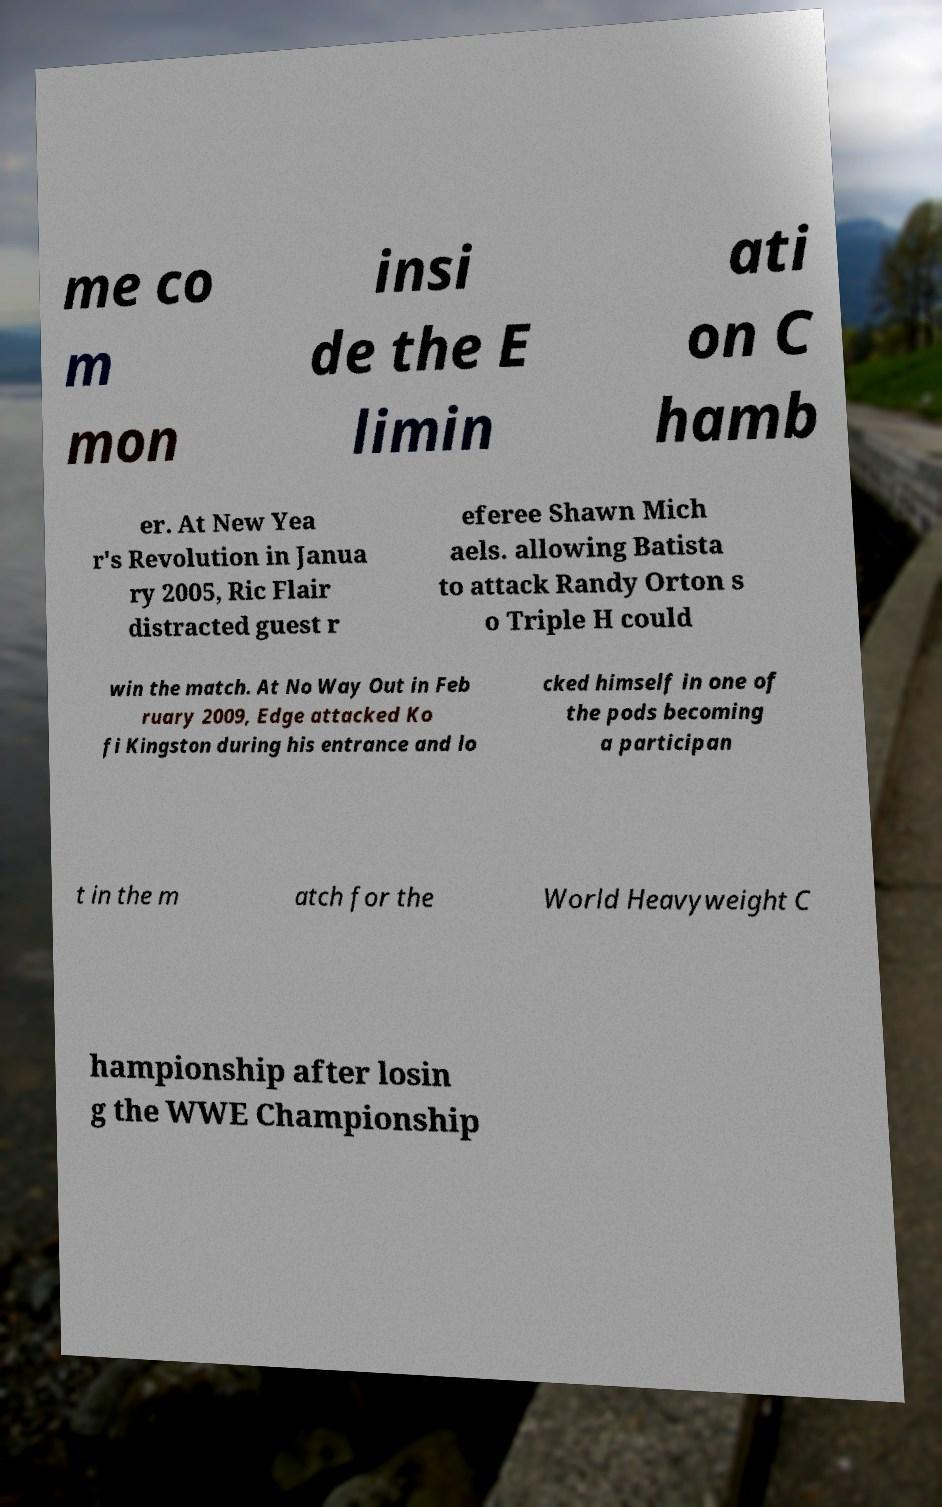Can you accurately transcribe the text from the provided image for me? me co m mon insi de the E limin ati on C hamb er. At New Yea r's Revolution in Janua ry 2005, Ric Flair distracted guest r eferee Shawn Mich aels. allowing Batista to attack Randy Orton s o Triple H could win the match. At No Way Out in Feb ruary 2009, Edge attacked Ko fi Kingston during his entrance and lo cked himself in one of the pods becoming a participan t in the m atch for the World Heavyweight C hampionship after losin g the WWE Championship 